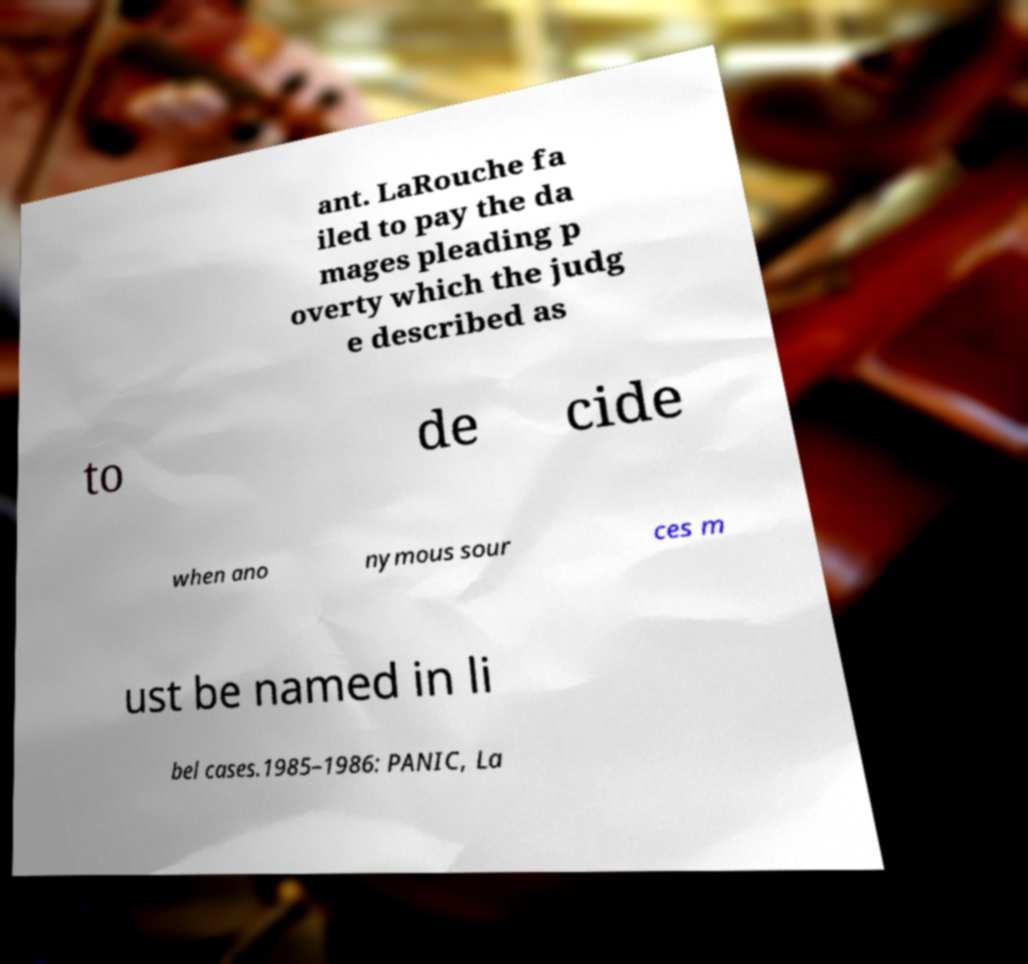There's text embedded in this image that I need extracted. Can you transcribe it verbatim? ant. LaRouche fa iled to pay the da mages pleading p overty which the judg e described as to de cide when ano nymous sour ces m ust be named in li bel cases.1985–1986: PANIC, La 